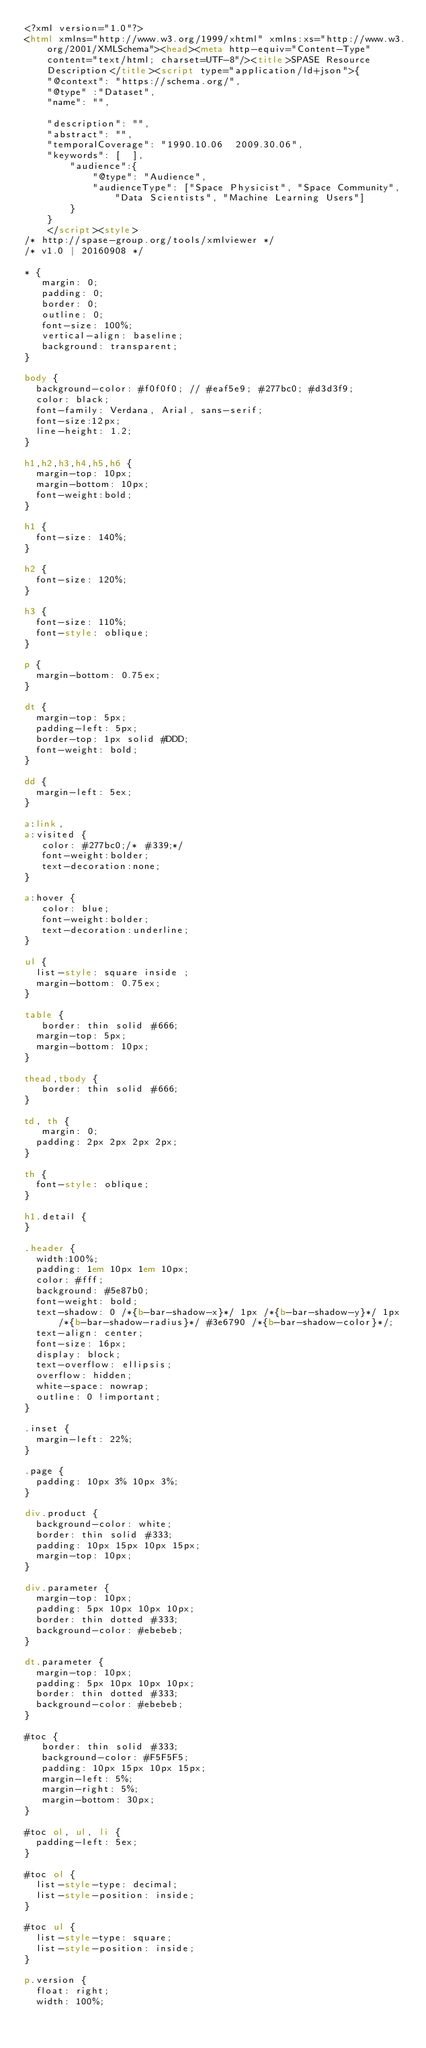Convert code to text. <code><loc_0><loc_0><loc_500><loc_500><_HTML_><?xml version="1.0"?>
<html xmlns="http://www.w3.org/1999/xhtml" xmlns:xs="http://www.w3.org/2001/XMLSchema"><head><meta http-equiv="Content-Type" content="text/html; charset=UTF-8"/><title>SPASE Resource Description</title><script type="application/ld+json">{
		"@context": "https://schema.org/",
		"@type" :"Dataset",
		"name": "",
     
 		"description": "",
		"abstract": "",
		"temporalCoverage": "1990.10.06  2009.30.06",
		"keywords": [  ],
        "audience":{
            "@type": "Audience",
            "audienceType": ["Space Physicist", "Space Community", "Data Scientists", "Machine Learning Users"]
        }
	  }
	  </script><style>
/* http://spase-group.org/tools/xmlviewer */
/* v1.0 | 20160908 */

* {
   margin: 0;
   padding: 0;
   border: 0;
   outline: 0;
   font-size: 100%;
   vertical-align: baseline;
   background: transparent;
}

body {
	background-color: #f0f0f0; // #eaf5e9; #277bc0; #d3d3f9;
	color: black;
	font-family: Verdana, Arial, sans-serif; 
	font-size:12px; 
	line-height: 1.2;
}
 
h1,h2,h3,h4,h5,h6 {
	margin-top: 10px;
	margin-bottom: 10px;
	font-weight:bold;
}

h1 {
	font-size: 140%;
}

h2 {
	font-size: 120%;
}

h3 {
	font-size: 110%;
	font-style: oblique;
}

p {
	margin-bottom: 0.75ex;
}

dt {
	margin-top: 5px;
	padding-left: 5px;
	border-top: 1px solid #DDD;
	font-weight: bold;
}

dd {
	margin-left: 5ex;
}

a:link,
a:visited {
   color: #277bc0;/* #339;*/
   font-weight:bolder; 
   text-decoration:none; 
}

a:hover {
   color: blue;
   font-weight:bolder; 
   text-decoration:underline; 
}

ul {
	list-style: square inside ;
	margin-bottom: 0.75ex;
}

table {
   border: thin solid #666;
	margin-top: 5px;
	margin-bottom: 10px;
}

thead,tbody {
   border: thin solid #666;
}

td, th {
   margin: 0;
	padding: 2px 2px 2px 2px;
}

th {
	font-style: oblique;
}

h1.detail {
}

.header {
	width:100%;
	padding: 1em 10px 1em 10px;
	color: #fff;
	background: #5e87b0;
	font-weight: bold;
	text-shadow: 0 /*{b-bar-shadow-x}*/ 1px /*{b-bar-shadow-y}*/ 1px /*{b-bar-shadow-radius}*/ #3e6790 /*{b-bar-shadow-color}*/;
	text-align: center;
	font-size: 16px;
	display: block;
	text-overflow: ellipsis;
	overflow: hidden;
	white-space: nowrap;
	outline: 0 !important;
}

.inset {
	margin-left: 22%;
}

.page {
	padding: 10px 3% 10px 3%;
}

div.product {
	background-color: white;
	border: thin solid #333;
	padding: 10px 15px 10px 15px;
	margin-top: 10px;
}

div.parameter {
	margin-top: 10px;
	padding: 5px 10px 10px 10px;
	border: thin dotted #333;
	background-color: #ebebeb;
}

dt.parameter {
	margin-top: 10px;
	padding: 5px 10px 10px 10px;
	border: thin dotted #333;
	background-color: #ebebeb;
}

#toc {
   border: thin solid #333;
   background-color: #F5F5F5; 
   padding: 10px 15px 10px 15px;
   margin-left: 5%;
   margin-right: 5%;
   margin-bottom: 30px;
}

#toc ol, ul, li {
	padding-left: 5ex;
}

#toc ol {
	list-style-type: decimal;
	list-style-position: inside; 
}

#toc ul {
	list-style-type: square;
	list-style-position: inside; 
}

p.version {
  float: right;
  width: 100%;</code> 